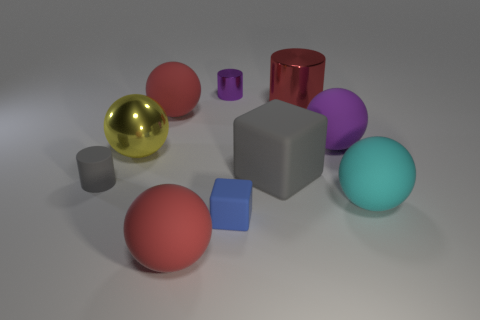How many objects are matte things in front of the blue cube or big cyan metallic things?
Your answer should be very brief. 1. There is a purple cylinder that is the same size as the blue matte object; what material is it?
Your response must be concise. Metal. The rubber ball in front of the large cyan sphere on the right side of the gray matte cylinder is what color?
Your answer should be compact. Red. How many purple shiny cylinders are to the right of the blue object?
Keep it short and to the point. 0. The big block is what color?
Your answer should be compact. Gray. How many big things are rubber blocks or purple things?
Your answer should be very brief. 2. There is a cylinder in front of the large red metallic cylinder; is its color the same as the matte block to the right of the tiny blue matte thing?
Keep it short and to the point. Yes. How many other things are the same color as the small matte block?
Offer a terse response. 0. The small matte object that is behind the cyan sphere has what shape?
Provide a short and direct response. Cylinder. Is the number of yellow metal spheres less than the number of tiny green metallic things?
Offer a terse response. No. 